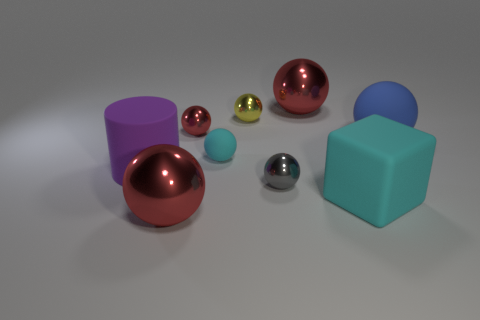What number of yellow things are cylinders or small metal things?
Your response must be concise. 1. Is there a cyan block that has the same size as the blue ball?
Ensure brevity in your answer.  Yes. How many big blocks are there?
Give a very brief answer. 1. How many large objects are cyan rubber cubes or metal things?
Provide a succinct answer. 3. The big metallic sphere on the left side of the large red metal thing that is behind the large metal sphere that is in front of the blue sphere is what color?
Give a very brief answer. Red. What number of other objects are the same color as the matte block?
Give a very brief answer. 1. What number of metal things are large cylinders or big blocks?
Provide a short and direct response. 0. There is a large shiny sphere that is in front of the tiny red thing; does it have the same color as the large shiny sphere that is behind the cyan rubber block?
Offer a very short reply. Yes. There is a cyan rubber thing that is the same shape as the yellow metallic thing; what is its size?
Your answer should be compact. Small. Is the number of big things to the right of the gray ball greater than the number of gray shiny cubes?
Provide a succinct answer. Yes. 